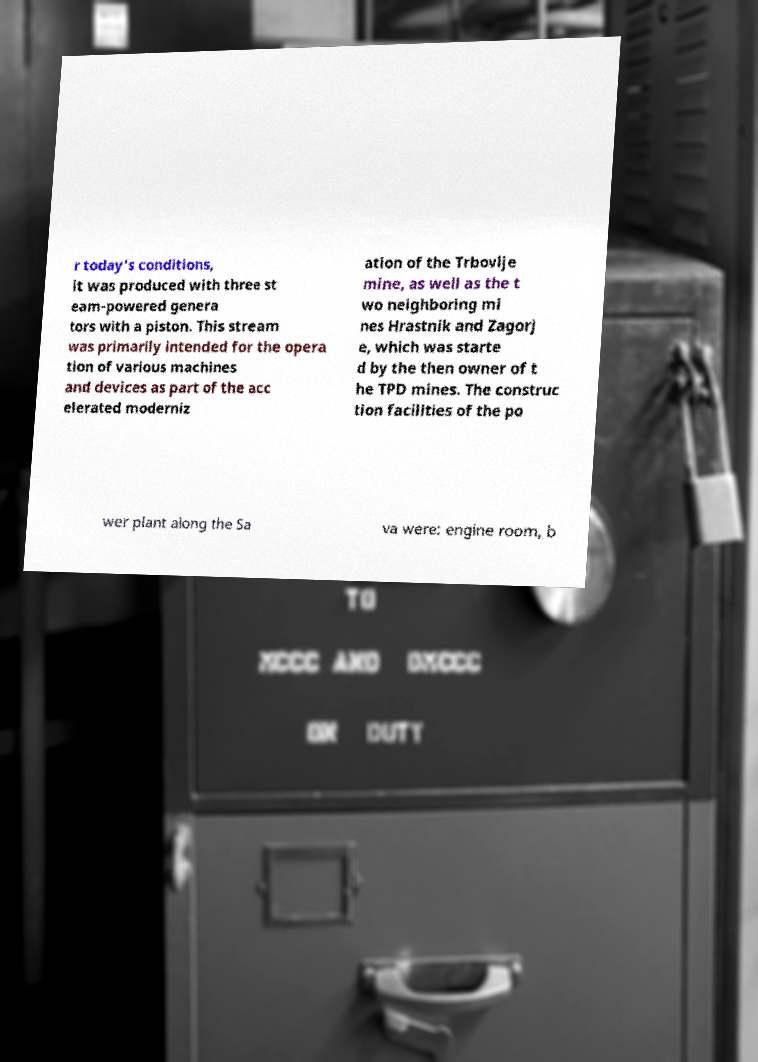There's text embedded in this image that I need extracted. Can you transcribe it verbatim? r today's conditions, it was produced with three st eam-powered genera tors with a piston. This stream was primarily intended for the opera tion of various machines and devices as part of the acc elerated moderniz ation of the Trbovlje mine, as well as the t wo neighboring mi nes Hrastnik and Zagorj e, which was starte d by the then owner of t he TPD mines. The construc tion facilities of the po wer plant along the Sa va were: engine room, b 